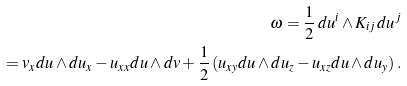Convert formula to latex. <formula><loc_0><loc_0><loc_500><loc_500>\omega = \frac { 1 } { 2 } \, d u ^ { i } \wedge K _ { i j } \, d u ^ { j } \\ \quad = v _ { x } d u \wedge d u _ { x } - u _ { x x } d u \wedge d v + \frac { 1 } { 2 } \left ( u _ { x y } d u \wedge d u _ { z } - u _ { x z } d u \wedge d u _ { y } \right ) .</formula> 